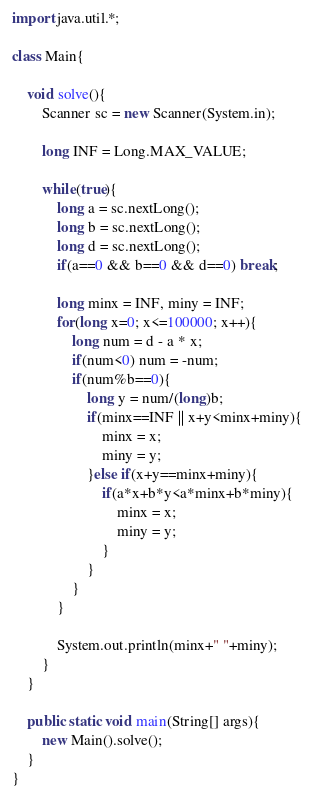Convert code to text. <code><loc_0><loc_0><loc_500><loc_500><_Java_>import java.util.*;

class Main{

    void solve(){
        Scanner sc = new Scanner(System.in);

        long INF = Long.MAX_VALUE;

        while(true){
            long a = sc.nextLong();
            long b = sc.nextLong();
            long d = sc.nextLong();
            if(a==0 && b==0 && d==0) break;

            long minx = INF, miny = INF;
            for(long x=0; x<=100000; x++){
                long num = d - a * x;
                if(num<0) num = -num;
                if(num%b==0){
                    long y = num/(long)b;
                    if(minx==INF || x+y<minx+miny){
                        minx = x;
                        miny = y;
                    }else if(x+y==minx+miny){
                        if(a*x+b*y<a*minx+b*miny){
                            minx = x;
                            miny = y;
                        }
                    }
                }
            }

            System.out.println(minx+" "+miny);
        }
    }

    public static void main(String[] args){
        new Main().solve();
    }
}</code> 